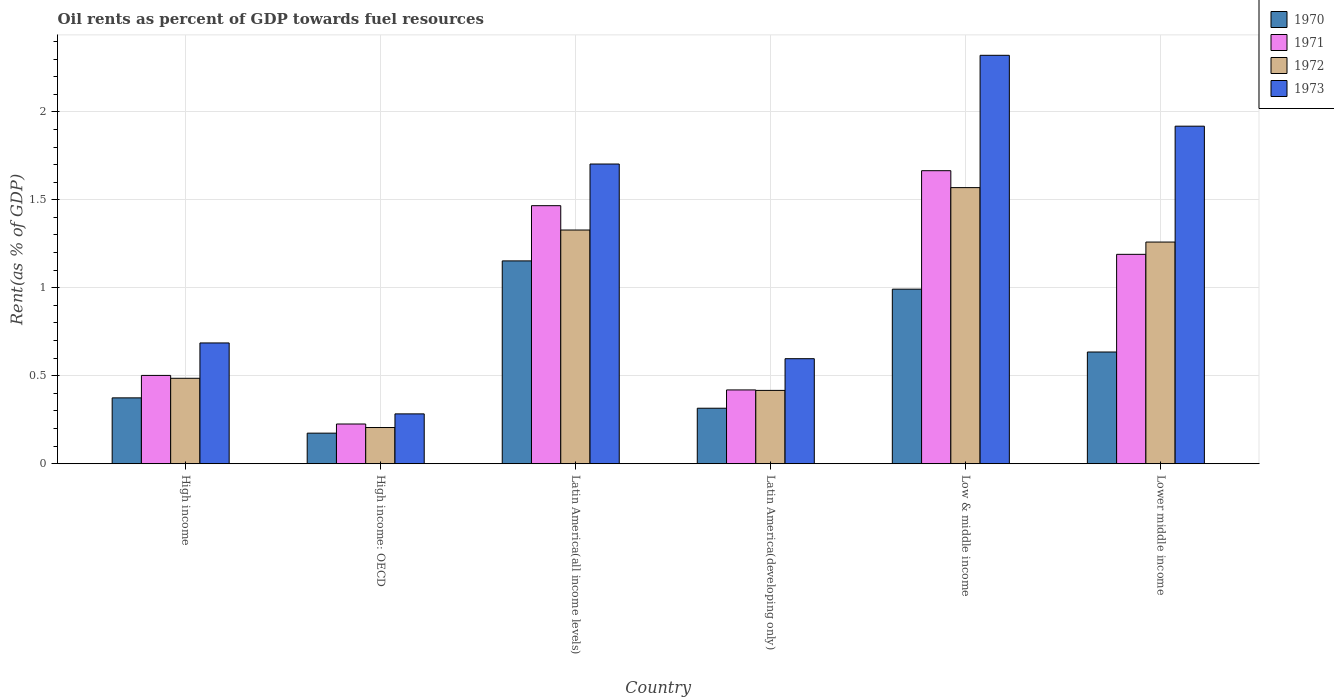How many groups of bars are there?
Your answer should be compact. 6. How many bars are there on the 1st tick from the left?
Your answer should be very brief. 4. What is the label of the 6th group of bars from the left?
Make the answer very short. Lower middle income. What is the oil rent in 1970 in High income: OECD?
Provide a succinct answer. 0.17. Across all countries, what is the maximum oil rent in 1970?
Give a very brief answer. 1.15. Across all countries, what is the minimum oil rent in 1971?
Provide a succinct answer. 0.23. In which country was the oil rent in 1972 maximum?
Offer a very short reply. Low & middle income. In which country was the oil rent in 1972 minimum?
Your answer should be compact. High income: OECD. What is the total oil rent in 1970 in the graph?
Your answer should be very brief. 3.64. What is the difference between the oil rent in 1972 in Latin America(all income levels) and that in Lower middle income?
Your answer should be compact. 0.07. What is the difference between the oil rent in 1971 in Latin America(developing only) and the oil rent in 1973 in Low & middle income?
Offer a very short reply. -1.9. What is the average oil rent in 1972 per country?
Ensure brevity in your answer.  0.88. What is the difference between the oil rent of/in 1972 and oil rent of/in 1971 in Latin America(developing only)?
Offer a terse response. -0. In how many countries, is the oil rent in 1973 greater than 1.3 %?
Provide a short and direct response. 3. What is the ratio of the oil rent in 1972 in High income to that in High income: OECD?
Make the answer very short. 2.36. Is the difference between the oil rent in 1972 in High income: OECD and Low & middle income greater than the difference between the oil rent in 1971 in High income: OECD and Low & middle income?
Provide a succinct answer. Yes. What is the difference between the highest and the second highest oil rent in 1973?
Keep it short and to the point. -0.4. What is the difference between the highest and the lowest oil rent in 1973?
Provide a succinct answer. 2.04. Is the sum of the oil rent in 1971 in Latin America(all income levels) and Latin America(developing only) greater than the maximum oil rent in 1973 across all countries?
Give a very brief answer. No. What does the 2nd bar from the left in Latin America(developing only) represents?
Provide a succinct answer. 1971. What does the 1st bar from the right in High income: OECD represents?
Your response must be concise. 1973. Are all the bars in the graph horizontal?
Provide a short and direct response. No. What is the difference between two consecutive major ticks on the Y-axis?
Offer a terse response. 0.5. Does the graph contain any zero values?
Your response must be concise. No. Does the graph contain grids?
Your answer should be very brief. Yes. What is the title of the graph?
Provide a succinct answer. Oil rents as percent of GDP towards fuel resources. What is the label or title of the Y-axis?
Keep it short and to the point. Rent(as % of GDP). What is the Rent(as % of GDP) in 1970 in High income?
Offer a very short reply. 0.37. What is the Rent(as % of GDP) of 1971 in High income?
Provide a short and direct response. 0.5. What is the Rent(as % of GDP) of 1972 in High income?
Offer a very short reply. 0.49. What is the Rent(as % of GDP) of 1973 in High income?
Offer a very short reply. 0.69. What is the Rent(as % of GDP) in 1970 in High income: OECD?
Offer a very short reply. 0.17. What is the Rent(as % of GDP) in 1971 in High income: OECD?
Ensure brevity in your answer.  0.23. What is the Rent(as % of GDP) of 1972 in High income: OECD?
Your response must be concise. 0.21. What is the Rent(as % of GDP) of 1973 in High income: OECD?
Offer a terse response. 0.28. What is the Rent(as % of GDP) in 1970 in Latin America(all income levels)?
Your response must be concise. 1.15. What is the Rent(as % of GDP) in 1971 in Latin America(all income levels)?
Provide a succinct answer. 1.47. What is the Rent(as % of GDP) in 1972 in Latin America(all income levels)?
Your response must be concise. 1.33. What is the Rent(as % of GDP) of 1973 in Latin America(all income levels)?
Your answer should be compact. 1.7. What is the Rent(as % of GDP) in 1970 in Latin America(developing only)?
Offer a very short reply. 0.32. What is the Rent(as % of GDP) of 1971 in Latin America(developing only)?
Give a very brief answer. 0.42. What is the Rent(as % of GDP) of 1972 in Latin America(developing only)?
Provide a short and direct response. 0.42. What is the Rent(as % of GDP) in 1973 in Latin America(developing only)?
Give a very brief answer. 0.6. What is the Rent(as % of GDP) in 1970 in Low & middle income?
Your response must be concise. 0.99. What is the Rent(as % of GDP) of 1971 in Low & middle income?
Offer a terse response. 1.67. What is the Rent(as % of GDP) of 1972 in Low & middle income?
Ensure brevity in your answer.  1.57. What is the Rent(as % of GDP) of 1973 in Low & middle income?
Ensure brevity in your answer.  2.32. What is the Rent(as % of GDP) in 1970 in Lower middle income?
Your response must be concise. 0.63. What is the Rent(as % of GDP) in 1971 in Lower middle income?
Your answer should be very brief. 1.19. What is the Rent(as % of GDP) of 1972 in Lower middle income?
Your answer should be very brief. 1.26. What is the Rent(as % of GDP) of 1973 in Lower middle income?
Your response must be concise. 1.92. Across all countries, what is the maximum Rent(as % of GDP) of 1970?
Your answer should be very brief. 1.15. Across all countries, what is the maximum Rent(as % of GDP) in 1971?
Give a very brief answer. 1.67. Across all countries, what is the maximum Rent(as % of GDP) of 1972?
Keep it short and to the point. 1.57. Across all countries, what is the maximum Rent(as % of GDP) of 1973?
Your answer should be very brief. 2.32. Across all countries, what is the minimum Rent(as % of GDP) of 1970?
Provide a succinct answer. 0.17. Across all countries, what is the minimum Rent(as % of GDP) of 1971?
Provide a succinct answer. 0.23. Across all countries, what is the minimum Rent(as % of GDP) of 1972?
Keep it short and to the point. 0.21. Across all countries, what is the minimum Rent(as % of GDP) in 1973?
Offer a terse response. 0.28. What is the total Rent(as % of GDP) of 1970 in the graph?
Provide a succinct answer. 3.64. What is the total Rent(as % of GDP) in 1971 in the graph?
Provide a short and direct response. 5.47. What is the total Rent(as % of GDP) in 1972 in the graph?
Provide a succinct answer. 5.27. What is the total Rent(as % of GDP) of 1973 in the graph?
Give a very brief answer. 7.51. What is the difference between the Rent(as % of GDP) of 1970 in High income and that in High income: OECD?
Provide a short and direct response. 0.2. What is the difference between the Rent(as % of GDP) of 1971 in High income and that in High income: OECD?
Your response must be concise. 0.28. What is the difference between the Rent(as % of GDP) in 1972 in High income and that in High income: OECD?
Offer a terse response. 0.28. What is the difference between the Rent(as % of GDP) in 1973 in High income and that in High income: OECD?
Provide a short and direct response. 0.4. What is the difference between the Rent(as % of GDP) in 1970 in High income and that in Latin America(all income levels)?
Give a very brief answer. -0.78. What is the difference between the Rent(as % of GDP) of 1971 in High income and that in Latin America(all income levels)?
Keep it short and to the point. -0.96. What is the difference between the Rent(as % of GDP) in 1972 in High income and that in Latin America(all income levels)?
Provide a short and direct response. -0.84. What is the difference between the Rent(as % of GDP) of 1973 in High income and that in Latin America(all income levels)?
Provide a succinct answer. -1.02. What is the difference between the Rent(as % of GDP) in 1970 in High income and that in Latin America(developing only)?
Offer a terse response. 0.06. What is the difference between the Rent(as % of GDP) in 1971 in High income and that in Latin America(developing only)?
Offer a terse response. 0.08. What is the difference between the Rent(as % of GDP) in 1972 in High income and that in Latin America(developing only)?
Keep it short and to the point. 0.07. What is the difference between the Rent(as % of GDP) of 1973 in High income and that in Latin America(developing only)?
Your answer should be compact. 0.09. What is the difference between the Rent(as % of GDP) of 1970 in High income and that in Low & middle income?
Keep it short and to the point. -0.62. What is the difference between the Rent(as % of GDP) in 1971 in High income and that in Low & middle income?
Make the answer very short. -1.16. What is the difference between the Rent(as % of GDP) in 1972 in High income and that in Low & middle income?
Offer a terse response. -1.08. What is the difference between the Rent(as % of GDP) of 1973 in High income and that in Low & middle income?
Your answer should be very brief. -1.63. What is the difference between the Rent(as % of GDP) of 1970 in High income and that in Lower middle income?
Offer a terse response. -0.26. What is the difference between the Rent(as % of GDP) in 1971 in High income and that in Lower middle income?
Give a very brief answer. -0.69. What is the difference between the Rent(as % of GDP) in 1972 in High income and that in Lower middle income?
Your answer should be very brief. -0.77. What is the difference between the Rent(as % of GDP) in 1973 in High income and that in Lower middle income?
Your answer should be very brief. -1.23. What is the difference between the Rent(as % of GDP) in 1970 in High income: OECD and that in Latin America(all income levels)?
Make the answer very short. -0.98. What is the difference between the Rent(as % of GDP) in 1971 in High income: OECD and that in Latin America(all income levels)?
Your answer should be compact. -1.24. What is the difference between the Rent(as % of GDP) of 1972 in High income: OECD and that in Latin America(all income levels)?
Keep it short and to the point. -1.12. What is the difference between the Rent(as % of GDP) in 1973 in High income: OECD and that in Latin America(all income levels)?
Your response must be concise. -1.42. What is the difference between the Rent(as % of GDP) in 1970 in High income: OECD and that in Latin America(developing only)?
Ensure brevity in your answer.  -0.14. What is the difference between the Rent(as % of GDP) of 1971 in High income: OECD and that in Latin America(developing only)?
Provide a short and direct response. -0.19. What is the difference between the Rent(as % of GDP) of 1972 in High income: OECD and that in Latin America(developing only)?
Your answer should be very brief. -0.21. What is the difference between the Rent(as % of GDP) of 1973 in High income: OECD and that in Latin America(developing only)?
Your response must be concise. -0.31. What is the difference between the Rent(as % of GDP) in 1970 in High income: OECD and that in Low & middle income?
Your answer should be very brief. -0.82. What is the difference between the Rent(as % of GDP) of 1971 in High income: OECD and that in Low & middle income?
Your answer should be very brief. -1.44. What is the difference between the Rent(as % of GDP) in 1972 in High income: OECD and that in Low & middle income?
Offer a terse response. -1.36. What is the difference between the Rent(as % of GDP) in 1973 in High income: OECD and that in Low & middle income?
Ensure brevity in your answer.  -2.04. What is the difference between the Rent(as % of GDP) of 1970 in High income: OECD and that in Lower middle income?
Keep it short and to the point. -0.46. What is the difference between the Rent(as % of GDP) of 1971 in High income: OECD and that in Lower middle income?
Make the answer very short. -0.96. What is the difference between the Rent(as % of GDP) in 1972 in High income: OECD and that in Lower middle income?
Your answer should be compact. -1.05. What is the difference between the Rent(as % of GDP) of 1973 in High income: OECD and that in Lower middle income?
Your answer should be compact. -1.64. What is the difference between the Rent(as % of GDP) in 1970 in Latin America(all income levels) and that in Latin America(developing only)?
Your response must be concise. 0.84. What is the difference between the Rent(as % of GDP) of 1971 in Latin America(all income levels) and that in Latin America(developing only)?
Your answer should be very brief. 1.05. What is the difference between the Rent(as % of GDP) in 1972 in Latin America(all income levels) and that in Latin America(developing only)?
Provide a short and direct response. 0.91. What is the difference between the Rent(as % of GDP) of 1973 in Latin America(all income levels) and that in Latin America(developing only)?
Offer a terse response. 1.11. What is the difference between the Rent(as % of GDP) of 1970 in Latin America(all income levels) and that in Low & middle income?
Your answer should be compact. 0.16. What is the difference between the Rent(as % of GDP) in 1971 in Latin America(all income levels) and that in Low & middle income?
Offer a terse response. -0.2. What is the difference between the Rent(as % of GDP) of 1972 in Latin America(all income levels) and that in Low & middle income?
Your response must be concise. -0.24. What is the difference between the Rent(as % of GDP) in 1973 in Latin America(all income levels) and that in Low & middle income?
Your answer should be compact. -0.62. What is the difference between the Rent(as % of GDP) of 1970 in Latin America(all income levels) and that in Lower middle income?
Provide a succinct answer. 0.52. What is the difference between the Rent(as % of GDP) in 1971 in Latin America(all income levels) and that in Lower middle income?
Keep it short and to the point. 0.28. What is the difference between the Rent(as % of GDP) in 1972 in Latin America(all income levels) and that in Lower middle income?
Offer a very short reply. 0.07. What is the difference between the Rent(as % of GDP) in 1973 in Latin America(all income levels) and that in Lower middle income?
Offer a very short reply. -0.21. What is the difference between the Rent(as % of GDP) of 1970 in Latin America(developing only) and that in Low & middle income?
Keep it short and to the point. -0.68. What is the difference between the Rent(as % of GDP) in 1971 in Latin America(developing only) and that in Low & middle income?
Keep it short and to the point. -1.25. What is the difference between the Rent(as % of GDP) in 1972 in Latin America(developing only) and that in Low & middle income?
Make the answer very short. -1.15. What is the difference between the Rent(as % of GDP) of 1973 in Latin America(developing only) and that in Low & middle income?
Make the answer very short. -1.72. What is the difference between the Rent(as % of GDP) of 1970 in Latin America(developing only) and that in Lower middle income?
Provide a succinct answer. -0.32. What is the difference between the Rent(as % of GDP) of 1971 in Latin America(developing only) and that in Lower middle income?
Offer a terse response. -0.77. What is the difference between the Rent(as % of GDP) in 1972 in Latin America(developing only) and that in Lower middle income?
Your response must be concise. -0.84. What is the difference between the Rent(as % of GDP) in 1973 in Latin America(developing only) and that in Lower middle income?
Your answer should be compact. -1.32. What is the difference between the Rent(as % of GDP) of 1970 in Low & middle income and that in Lower middle income?
Your answer should be very brief. 0.36. What is the difference between the Rent(as % of GDP) of 1971 in Low & middle income and that in Lower middle income?
Ensure brevity in your answer.  0.48. What is the difference between the Rent(as % of GDP) of 1972 in Low & middle income and that in Lower middle income?
Offer a very short reply. 0.31. What is the difference between the Rent(as % of GDP) of 1973 in Low & middle income and that in Lower middle income?
Provide a short and direct response. 0.4. What is the difference between the Rent(as % of GDP) in 1970 in High income and the Rent(as % of GDP) in 1971 in High income: OECD?
Your answer should be compact. 0.15. What is the difference between the Rent(as % of GDP) of 1970 in High income and the Rent(as % of GDP) of 1972 in High income: OECD?
Keep it short and to the point. 0.17. What is the difference between the Rent(as % of GDP) of 1970 in High income and the Rent(as % of GDP) of 1973 in High income: OECD?
Provide a succinct answer. 0.09. What is the difference between the Rent(as % of GDP) of 1971 in High income and the Rent(as % of GDP) of 1972 in High income: OECD?
Your response must be concise. 0.3. What is the difference between the Rent(as % of GDP) of 1971 in High income and the Rent(as % of GDP) of 1973 in High income: OECD?
Offer a very short reply. 0.22. What is the difference between the Rent(as % of GDP) in 1972 in High income and the Rent(as % of GDP) in 1973 in High income: OECD?
Offer a very short reply. 0.2. What is the difference between the Rent(as % of GDP) in 1970 in High income and the Rent(as % of GDP) in 1971 in Latin America(all income levels)?
Keep it short and to the point. -1.09. What is the difference between the Rent(as % of GDP) of 1970 in High income and the Rent(as % of GDP) of 1972 in Latin America(all income levels)?
Keep it short and to the point. -0.95. What is the difference between the Rent(as % of GDP) of 1970 in High income and the Rent(as % of GDP) of 1973 in Latin America(all income levels)?
Your answer should be very brief. -1.33. What is the difference between the Rent(as % of GDP) in 1971 in High income and the Rent(as % of GDP) in 1972 in Latin America(all income levels)?
Provide a succinct answer. -0.83. What is the difference between the Rent(as % of GDP) in 1971 in High income and the Rent(as % of GDP) in 1973 in Latin America(all income levels)?
Your answer should be very brief. -1.2. What is the difference between the Rent(as % of GDP) of 1972 in High income and the Rent(as % of GDP) of 1973 in Latin America(all income levels)?
Your answer should be very brief. -1.22. What is the difference between the Rent(as % of GDP) in 1970 in High income and the Rent(as % of GDP) in 1971 in Latin America(developing only)?
Your answer should be very brief. -0.05. What is the difference between the Rent(as % of GDP) of 1970 in High income and the Rent(as % of GDP) of 1972 in Latin America(developing only)?
Your answer should be very brief. -0.04. What is the difference between the Rent(as % of GDP) in 1970 in High income and the Rent(as % of GDP) in 1973 in Latin America(developing only)?
Ensure brevity in your answer.  -0.22. What is the difference between the Rent(as % of GDP) in 1971 in High income and the Rent(as % of GDP) in 1972 in Latin America(developing only)?
Make the answer very short. 0.09. What is the difference between the Rent(as % of GDP) of 1971 in High income and the Rent(as % of GDP) of 1973 in Latin America(developing only)?
Your response must be concise. -0.1. What is the difference between the Rent(as % of GDP) of 1972 in High income and the Rent(as % of GDP) of 1973 in Latin America(developing only)?
Your answer should be compact. -0.11. What is the difference between the Rent(as % of GDP) in 1970 in High income and the Rent(as % of GDP) in 1971 in Low & middle income?
Provide a succinct answer. -1.29. What is the difference between the Rent(as % of GDP) in 1970 in High income and the Rent(as % of GDP) in 1972 in Low & middle income?
Give a very brief answer. -1.19. What is the difference between the Rent(as % of GDP) of 1970 in High income and the Rent(as % of GDP) of 1973 in Low & middle income?
Provide a short and direct response. -1.95. What is the difference between the Rent(as % of GDP) in 1971 in High income and the Rent(as % of GDP) in 1972 in Low & middle income?
Your response must be concise. -1.07. What is the difference between the Rent(as % of GDP) of 1971 in High income and the Rent(as % of GDP) of 1973 in Low & middle income?
Your answer should be compact. -1.82. What is the difference between the Rent(as % of GDP) in 1972 in High income and the Rent(as % of GDP) in 1973 in Low & middle income?
Give a very brief answer. -1.84. What is the difference between the Rent(as % of GDP) of 1970 in High income and the Rent(as % of GDP) of 1971 in Lower middle income?
Your answer should be compact. -0.82. What is the difference between the Rent(as % of GDP) in 1970 in High income and the Rent(as % of GDP) in 1972 in Lower middle income?
Offer a terse response. -0.89. What is the difference between the Rent(as % of GDP) in 1970 in High income and the Rent(as % of GDP) in 1973 in Lower middle income?
Provide a short and direct response. -1.54. What is the difference between the Rent(as % of GDP) in 1971 in High income and the Rent(as % of GDP) in 1972 in Lower middle income?
Your answer should be very brief. -0.76. What is the difference between the Rent(as % of GDP) in 1971 in High income and the Rent(as % of GDP) in 1973 in Lower middle income?
Ensure brevity in your answer.  -1.42. What is the difference between the Rent(as % of GDP) of 1972 in High income and the Rent(as % of GDP) of 1973 in Lower middle income?
Offer a very short reply. -1.43. What is the difference between the Rent(as % of GDP) of 1970 in High income: OECD and the Rent(as % of GDP) of 1971 in Latin America(all income levels)?
Your response must be concise. -1.29. What is the difference between the Rent(as % of GDP) in 1970 in High income: OECD and the Rent(as % of GDP) in 1972 in Latin America(all income levels)?
Ensure brevity in your answer.  -1.15. What is the difference between the Rent(as % of GDP) in 1970 in High income: OECD and the Rent(as % of GDP) in 1973 in Latin America(all income levels)?
Your response must be concise. -1.53. What is the difference between the Rent(as % of GDP) of 1971 in High income: OECD and the Rent(as % of GDP) of 1972 in Latin America(all income levels)?
Your answer should be very brief. -1.1. What is the difference between the Rent(as % of GDP) of 1971 in High income: OECD and the Rent(as % of GDP) of 1973 in Latin America(all income levels)?
Give a very brief answer. -1.48. What is the difference between the Rent(as % of GDP) in 1972 in High income: OECD and the Rent(as % of GDP) in 1973 in Latin America(all income levels)?
Provide a succinct answer. -1.5. What is the difference between the Rent(as % of GDP) in 1970 in High income: OECD and the Rent(as % of GDP) in 1971 in Latin America(developing only)?
Ensure brevity in your answer.  -0.25. What is the difference between the Rent(as % of GDP) of 1970 in High income: OECD and the Rent(as % of GDP) of 1972 in Latin America(developing only)?
Offer a very short reply. -0.24. What is the difference between the Rent(as % of GDP) in 1970 in High income: OECD and the Rent(as % of GDP) in 1973 in Latin America(developing only)?
Your answer should be compact. -0.42. What is the difference between the Rent(as % of GDP) in 1971 in High income: OECD and the Rent(as % of GDP) in 1972 in Latin America(developing only)?
Make the answer very short. -0.19. What is the difference between the Rent(as % of GDP) of 1971 in High income: OECD and the Rent(as % of GDP) of 1973 in Latin America(developing only)?
Ensure brevity in your answer.  -0.37. What is the difference between the Rent(as % of GDP) of 1972 in High income: OECD and the Rent(as % of GDP) of 1973 in Latin America(developing only)?
Ensure brevity in your answer.  -0.39. What is the difference between the Rent(as % of GDP) in 1970 in High income: OECD and the Rent(as % of GDP) in 1971 in Low & middle income?
Make the answer very short. -1.49. What is the difference between the Rent(as % of GDP) of 1970 in High income: OECD and the Rent(as % of GDP) of 1972 in Low & middle income?
Make the answer very short. -1.4. What is the difference between the Rent(as % of GDP) of 1970 in High income: OECD and the Rent(as % of GDP) of 1973 in Low & middle income?
Ensure brevity in your answer.  -2.15. What is the difference between the Rent(as % of GDP) of 1971 in High income: OECD and the Rent(as % of GDP) of 1972 in Low & middle income?
Your answer should be compact. -1.34. What is the difference between the Rent(as % of GDP) of 1971 in High income: OECD and the Rent(as % of GDP) of 1973 in Low & middle income?
Provide a short and direct response. -2.1. What is the difference between the Rent(as % of GDP) of 1972 in High income: OECD and the Rent(as % of GDP) of 1973 in Low & middle income?
Offer a very short reply. -2.12. What is the difference between the Rent(as % of GDP) in 1970 in High income: OECD and the Rent(as % of GDP) in 1971 in Lower middle income?
Your answer should be very brief. -1.02. What is the difference between the Rent(as % of GDP) of 1970 in High income: OECD and the Rent(as % of GDP) of 1972 in Lower middle income?
Ensure brevity in your answer.  -1.09. What is the difference between the Rent(as % of GDP) in 1970 in High income: OECD and the Rent(as % of GDP) in 1973 in Lower middle income?
Make the answer very short. -1.74. What is the difference between the Rent(as % of GDP) in 1971 in High income: OECD and the Rent(as % of GDP) in 1972 in Lower middle income?
Offer a very short reply. -1.03. What is the difference between the Rent(as % of GDP) of 1971 in High income: OECD and the Rent(as % of GDP) of 1973 in Lower middle income?
Make the answer very short. -1.69. What is the difference between the Rent(as % of GDP) in 1972 in High income: OECD and the Rent(as % of GDP) in 1973 in Lower middle income?
Offer a very short reply. -1.71. What is the difference between the Rent(as % of GDP) of 1970 in Latin America(all income levels) and the Rent(as % of GDP) of 1971 in Latin America(developing only)?
Ensure brevity in your answer.  0.73. What is the difference between the Rent(as % of GDP) in 1970 in Latin America(all income levels) and the Rent(as % of GDP) in 1972 in Latin America(developing only)?
Give a very brief answer. 0.74. What is the difference between the Rent(as % of GDP) of 1970 in Latin America(all income levels) and the Rent(as % of GDP) of 1973 in Latin America(developing only)?
Your answer should be compact. 0.56. What is the difference between the Rent(as % of GDP) in 1971 in Latin America(all income levels) and the Rent(as % of GDP) in 1972 in Latin America(developing only)?
Offer a terse response. 1.05. What is the difference between the Rent(as % of GDP) of 1971 in Latin America(all income levels) and the Rent(as % of GDP) of 1973 in Latin America(developing only)?
Give a very brief answer. 0.87. What is the difference between the Rent(as % of GDP) of 1972 in Latin America(all income levels) and the Rent(as % of GDP) of 1973 in Latin America(developing only)?
Your response must be concise. 0.73. What is the difference between the Rent(as % of GDP) in 1970 in Latin America(all income levels) and the Rent(as % of GDP) in 1971 in Low & middle income?
Your response must be concise. -0.51. What is the difference between the Rent(as % of GDP) of 1970 in Latin America(all income levels) and the Rent(as % of GDP) of 1972 in Low & middle income?
Offer a very short reply. -0.42. What is the difference between the Rent(as % of GDP) in 1970 in Latin America(all income levels) and the Rent(as % of GDP) in 1973 in Low & middle income?
Offer a very short reply. -1.17. What is the difference between the Rent(as % of GDP) in 1971 in Latin America(all income levels) and the Rent(as % of GDP) in 1972 in Low & middle income?
Ensure brevity in your answer.  -0.1. What is the difference between the Rent(as % of GDP) of 1971 in Latin America(all income levels) and the Rent(as % of GDP) of 1973 in Low & middle income?
Your answer should be compact. -0.85. What is the difference between the Rent(as % of GDP) in 1972 in Latin America(all income levels) and the Rent(as % of GDP) in 1973 in Low & middle income?
Give a very brief answer. -0.99. What is the difference between the Rent(as % of GDP) of 1970 in Latin America(all income levels) and the Rent(as % of GDP) of 1971 in Lower middle income?
Offer a terse response. -0.04. What is the difference between the Rent(as % of GDP) in 1970 in Latin America(all income levels) and the Rent(as % of GDP) in 1972 in Lower middle income?
Provide a succinct answer. -0.11. What is the difference between the Rent(as % of GDP) in 1970 in Latin America(all income levels) and the Rent(as % of GDP) in 1973 in Lower middle income?
Offer a terse response. -0.77. What is the difference between the Rent(as % of GDP) in 1971 in Latin America(all income levels) and the Rent(as % of GDP) in 1972 in Lower middle income?
Offer a terse response. 0.21. What is the difference between the Rent(as % of GDP) of 1971 in Latin America(all income levels) and the Rent(as % of GDP) of 1973 in Lower middle income?
Provide a short and direct response. -0.45. What is the difference between the Rent(as % of GDP) of 1972 in Latin America(all income levels) and the Rent(as % of GDP) of 1973 in Lower middle income?
Offer a very short reply. -0.59. What is the difference between the Rent(as % of GDP) of 1970 in Latin America(developing only) and the Rent(as % of GDP) of 1971 in Low & middle income?
Provide a succinct answer. -1.35. What is the difference between the Rent(as % of GDP) of 1970 in Latin America(developing only) and the Rent(as % of GDP) of 1972 in Low & middle income?
Give a very brief answer. -1.25. What is the difference between the Rent(as % of GDP) of 1970 in Latin America(developing only) and the Rent(as % of GDP) of 1973 in Low & middle income?
Make the answer very short. -2.01. What is the difference between the Rent(as % of GDP) in 1971 in Latin America(developing only) and the Rent(as % of GDP) in 1972 in Low & middle income?
Make the answer very short. -1.15. What is the difference between the Rent(as % of GDP) in 1971 in Latin America(developing only) and the Rent(as % of GDP) in 1973 in Low & middle income?
Provide a succinct answer. -1.9. What is the difference between the Rent(as % of GDP) of 1972 in Latin America(developing only) and the Rent(as % of GDP) of 1973 in Low & middle income?
Keep it short and to the point. -1.9. What is the difference between the Rent(as % of GDP) of 1970 in Latin America(developing only) and the Rent(as % of GDP) of 1971 in Lower middle income?
Give a very brief answer. -0.87. What is the difference between the Rent(as % of GDP) in 1970 in Latin America(developing only) and the Rent(as % of GDP) in 1972 in Lower middle income?
Your answer should be compact. -0.94. What is the difference between the Rent(as % of GDP) in 1970 in Latin America(developing only) and the Rent(as % of GDP) in 1973 in Lower middle income?
Your answer should be compact. -1.6. What is the difference between the Rent(as % of GDP) of 1971 in Latin America(developing only) and the Rent(as % of GDP) of 1972 in Lower middle income?
Your answer should be very brief. -0.84. What is the difference between the Rent(as % of GDP) in 1971 in Latin America(developing only) and the Rent(as % of GDP) in 1973 in Lower middle income?
Ensure brevity in your answer.  -1.5. What is the difference between the Rent(as % of GDP) of 1972 in Latin America(developing only) and the Rent(as % of GDP) of 1973 in Lower middle income?
Keep it short and to the point. -1.5. What is the difference between the Rent(as % of GDP) in 1970 in Low & middle income and the Rent(as % of GDP) in 1971 in Lower middle income?
Your answer should be very brief. -0.2. What is the difference between the Rent(as % of GDP) of 1970 in Low & middle income and the Rent(as % of GDP) of 1972 in Lower middle income?
Offer a very short reply. -0.27. What is the difference between the Rent(as % of GDP) of 1970 in Low & middle income and the Rent(as % of GDP) of 1973 in Lower middle income?
Make the answer very short. -0.93. What is the difference between the Rent(as % of GDP) in 1971 in Low & middle income and the Rent(as % of GDP) in 1972 in Lower middle income?
Your response must be concise. 0.41. What is the difference between the Rent(as % of GDP) of 1971 in Low & middle income and the Rent(as % of GDP) of 1973 in Lower middle income?
Make the answer very short. -0.25. What is the difference between the Rent(as % of GDP) of 1972 in Low & middle income and the Rent(as % of GDP) of 1973 in Lower middle income?
Provide a succinct answer. -0.35. What is the average Rent(as % of GDP) in 1970 per country?
Your response must be concise. 0.61. What is the average Rent(as % of GDP) in 1971 per country?
Keep it short and to the point. 0.91. What is the average Rent(as % of GDP) in 1972 per country?
Offer a terse response. 0.88. What is the average Rent(as % of GDP) in 1973 per country?
Offer a terse response. 1.25. What is the difference between the Rent(as % of GDP) of 1970 and Rent(as % of GDP) of 1971 in High income?
Your response must be concise. -0.13. What is the difference between the Rent(as % of GDP) in 1970 and Rent(as % of GDP) in 1972 in High income?
Your answer should be very brief. -0.11. What is the difference between the Rent(as % of GDP) in 1970 and Rent(as % of GDP) in 1973 in High income?
Keep it short and to the point. -0.31. What is the difference between the Rent(as % of GDP) of 1971 and Rent(as % of GDP) of 1972 in High income?
Offer a very short reply. 0.02. What is the difference between the Rent(as % of GDP) in 1971 and Rent(as % of GDP) in 1973 in High income?
Ensure brevity in your answer.  -0.18. What is the difference between the Rent(as % of GDP) of 1972 and Rent(as % of GDP) of 1973 in High income?
Provide a short and direct response. -0.2. What is the difference between the Rent(as % of GDP) of 1970 and Rent(as % of GDP) of 1971 in High income: OECD?
Your answer should be very brief. -0.05. What is the difference between the Rent(as % of GDP) of 1970 and Rent(as % of GDP) of 1972 in High income: OECD?
Provide a short and direct response. -0.03. What is the difference between the Rent(as % of GDP) in 1970 and Rent(as % of GDP) in 1973 in High income: OECD?
Provide a short and direct response. -0.11. What is the difference between the Rent(as % of GDP) of 1971 and Rent(as % of GDP) of 1973 in High income: OECD?
Your answer should be very brief. -0.06. What is the difference between the Rent(as % of GDP) in 1972 and Rent(as % of GDP) in 1973 in High income: OECD?
Offer a very short reply. -0.08. What is the difference between the Rent(as % of GDP) of 1970 and Rent(as % of GDP) of 1971 in Latin America(all income levels)?
Your response must be concise. -0.31. What is the difference between the Rent(as % of GDP) in 1970 and Rent(as % of GDP) in 1972 in Latin America(all income levels)?
Your response must be concise. -0.18. What is the difference between the Rent(as % of GDP) in 1970 and Rent(as % of GDP) in 1973 in Latin America(all income levels)?
Your response must be concise. -0.55. What is the difference between the Rent(as % of GDP) in 1971 and Rent(as % of GDP) in 1972 in Latin America(all income levels)?
Provide a succinct answer. 0.14. What is the difference between the Rent(as % of GDP) in 1971 and Rent(as % of GDP) in 1973 in Latin America(all income levels)?
Give a very brief answer. -0.24. What is the difference between the Rent(as % of GDP) in 1972 and Rent(as % of GDP) in 1973 in Latin America(all income levels)?
Offer a terse response. -0.38. What is the difference between the Rent(as % of GDP) of 1970 and Rent(as % of GDP) of 1971 in Latin America(developing only)?
Offer a terse response. -0.1. What is the difference between the Rent(as % of GDP) in 1970 and Rent(as % of GDP) in 1972 in Latin America(developing only)?
Make the answer very short. -0.1. What is the difference between the Rent(as % of GDP) of 1970 and Rent(as % of GDP) of 1973 in Latin America(developing only)?
Make the answer very short. -0.28. What is the difference between the Rent(as % of GDP) in 1971 and Rent(as % of GDP) in 1972 in Latin America(developing only)?
Your answer should be compact. 0. What is the difference between the Rent(as % of GDP) in 1971 and Rent(as % of GDP) in 1973 in Latin America(developing only)?
Keep it short and to the point. -0.18. What is the difference between the Rent(as % of GDP) in 1972 and Rent(as % of GDP) in 1973 in Latin America(developing only)?
Your response must be concise. -0.18. What is the difference between the Rent(as % of GDP) of 1970 and Rent(as % of GDP) of 1971 in Low & middle income?
Your answer should be very brief. -0.67. What is the difference between the Rent(as % of GDP) in 1970 and Rent(as % of GDP) in 1972 in Low & middle income?
Keep it short and to the point. -0.58. What is the difference between the Rent(as % of GDP) of 1970 and Rent(as % of GDP) of 1973 in Low & middle income?
Your answer should be compact. -1.33. What is the difference between the Rent(as % of GDP) of 1971 and Rent(as % of GDP) of 1972 in Low & middle income?
Provide a succinct answer. 0.1. What is the difference between the Rent(as % of GDP) in 1971 and Rent(as % of GDP) in 1973 in Low & middle income?
Ensure brevity in your answer.  -0.66. What is the difference between the Rent(as % of GDP) of 1972 and Rent(as % of GDP) of 1973 in Low & middle income?
Give a very brief answer. -0.75. What is the difference between the Rent(as % of GDP) in 1970 and Rent(as % of GDP) in 1971 in Lower middle income?
Your response must be concise. -0.56. What is the difference between the Rent(as % of GDP) of 1970 and Rent(as % of GDP) of 1972 in Lower middle income?
Your answer should be compact. -0.62. What is the difference between the Rent(as % of GDP) of 1970 and Rent(as % of GDP) of 1973 in Lower middle income?
Offer a very short reply. -1.28. What is the difference between the Rent(as % of GDP) in 1971 and Rent(as % of GDP) in 1972 in Lower middle income?
Offer a terse response. -0.07. What is the difference between the Rent(as % of GDP) in 1971 and Rent(as % of GDP) in 1973 in Lower middle income?
Give a very brief answer. -0.73. What is the difference between the Rent(as % of GDP) in 1972 and Rent(as % of GDP) in 1973 in Lower middle income?
Give a very brief answer. -0.66. What is the ratio of the Rent(as % of GDP) of 1970 in High income to that in High income: OECD?
Your response must be concise. 2.15. What is the ratio of the Rent(as % of GDP) of 1971 in High income to that in High income: OECD?
Your answer should be very brief. 2.22. What is the ratio of the Rent(as % of GDP) of 1972 in High income to that in High income: OECD?
Your answer should be very brief. 2.36. What is the ratio of the Rent(as % of GDP) in 1973 in High income to that in High income: OECD?
Give a very brief answer. 2.42. What is the ratio of the Rent(as % of GDP) in 1970 in High income to that in Latin America(all income levels)?
Keep it short and to the point. 0.32. What is the ratio of the Rent(as % of GDP) in 1971 in High income to that in Latin America(all income levels)?
Your answer should be compact. 0.34. What is the ratio of the Rent(as % of GDP) in 1972 in High income to that in Latin America(all income levels)?
Offer a very short reply. 0.37. What is the ratio of the Rent(as % of GDP) in 1973 in High income to that in Latin America(all income levels)?
Your answer should be compact. 0.4. What is the ratio of the Rent(as % of GDP) in 1970 in High income to that in Latin America(developing only)?
Keep it short and to the point. 1.19. What is the ratio of the Rent(as % of GDP) of 1971 in High income to that in Latin America(developing only)?
Your response must be concise. 1.2. What is the ratio of the Rent(as % of GDP) in 1972 in High income to that in Latin America(developing only)?
Provide a short and direct response. 1.17. What is the ratio of the Rent(as % of GDP) in 1973 in High income to that in Latin America(developing only)?
Ensure brevity in your answer.  1.15. What is the ratio of the Rent(as % of GDP) in 1970 in High income to that in Low & middle income?
Give a very brief answer. 0.38. What is the ratio of the Rent(as % of GDP) in 1971 in High income to that in Low & middle income?
Keep it short and to the point. 0.3. What is the ratio of the Rent(as % of GDP) in 1972 in High income to that in Low & middle income?
Offer a terse response. 0.31. What is the ratio of the Rent(as % of GDP) in 1973 in High income to that in Low & middle income?
Provide a short and direct response. 0.3. What is the ratio of the Rent(as % of GDP) of 1970 in High income to that in Lower middle income?
Provide a succinct answer. 0.59. What is the ratio of the Rent(as % of GDP) in 1971 in High income to that in Lower middle income?
Offer a very short reply. 0.42. What is the ratio of the Rent(as % of GDP) in 1972 in High income to that in Lower middle income?
Offer a very short reply. 0.39. What is the ratio of the Rent(as % of GDP) of 1973 in High income to that in Lower middle income?
Your response must be concise. 0.36. What is the ratio of the Rent(as % of GDP) in 1970 in High income: OECD to that in Latin America(all income levels)?
Ensure brevity in your answer.  0.15. What is the ratio of the Rent(as % of GDP) of 1971 in High income: OECD to that in Latin America(all income levels)?
Offer a terse response. 0.15. What is the ratio of the Rent(as % of GDP) in 1972 in High income: OECD to that in Latin America(all income levels)?
Ensure brevity in your answer.  0.15. What is the ratio of the Rent(as % of GDP) of 1973 in High income: OECD to that in Latin America(all income levels)?
Your answer should be compact. 0.17. What is the ratio of the Rent(as % of GDP) of 1970 in High income: OECD to that in Latin America(developing only)?
Your answer should be compact. 0.55. What is the ratio of the Rent(as % of GDP) of 1971 in High income: OECD to that in Latin America(developing only)?
Your answer should be compact. 0.54. What is the ratio of the Rent(as % of GDP) of 1972 in High income: OECD to that in Latin America(developing only)?
Make the answer very short. 0.49. What is the ratio of the Rent(as % of GDP) of 1973 in High income: OECD to that in Latin America(developing only)?
Give a very brief answer. 0.47. What is the ratio of the Rent(as % of GDP) in 1970 in High income: OECD to that in Low & middle income?
Provide a short and direct response. 0.18. What is the ratio of the Rent(as % of GDP) in 1971 in High income: OECD to that in Low & middle income?
Give a very brief answer. 0.14. What is the ratio of the Rent(as % of GDP) in 1972 in High income: OECD to that in Low & middle income?
Make the answer very short. 0.13. What is the ratio of the Rent(as % of GDP) in 1973 in High income: OECD to that in Low & middle income?
Make the answer very short. 0.12. What is the ratio of the Rent(as % of GDP) in 1970 in High income: OECD to that in Lower middle income?
Make the answer very short. 0.27. What is the ratio of the Rent(as % of GDP) of 1971 in High income: OECD to that in Lower middle income?
Keep it short and to the point. 0.19. What is the ratio of the Rent(as % of GDP) of 1972 in High income: OECD to that in Lower middle income?
Offer a very short reply. 0.16. What is the ratio of the Rent(as % of GDP) in 1973 in High income: OECD to that in Lower middle income?
Provide a succinct answer. 0.15. What is the ratio of the Rent(as % of GDP) of 1970 in Latin America(all income levels) to that in Latin America(developing only)?
Your response must be concise. 3.65. What is the ratio of the Rent(as % of GDP) in 1971 in Latin America(all income levels) to that in Latin America(developing only)?
Your response must be concise. 3.5. What is the ratio of the Rent(as % of GDP) in 1972 in Latin America(all income levels) to that in Latin America(developing only)?
Keep it short and to the point. 3.19. What is the ratio of the Rent(as % of GDP) in 1973 in Latin America(all income levels) to that in Latin America(developing only)?
Offer a terse response. 2.85. What is the ratio of the Rent(as % of GDP) in 1970 in Latin America(all income levels) to that in Low & middle income?
Your response must be concise. 1.16. What is the ratio of the Rent(as % of GDP) in 1971 in Latin America(all income levels) to that in Low & middle income?
Offer a terse response. 0.88. What is the ratio of the Rent(as % of GDP) of 1972 in Latin America(all income levels) to that in Low & middle income?
Provide a short and direct response. 0.85. What is the ratio of the Rent(as % of GDP) of 1973 in Latin America(all income levels) to that in Low & middle income?
Your response must be concise. 0.73. What is the ratio of the Rent(as % of GDP) in 1970 in Latin America(all income levels) to that in Lower middle income?
Give a very brief answer. 1.82. What is the ratio of the Rent(as % of GDP) of 1971 in Latin America(all income levels) to that in Lower middle income?
Ensure brevity in your answer.  1.23. What is the ratio of the Rent(as % of GDP) of 1972 in Latin America(all income levels) to that in Lower middle income?
Provide a succinct answer. 1.05. What is the ratio of the Rent(as % of GDP) of 1973 in Latin America(all income levels) to that in Lower middle income?
Offer a terse response. 0.89. What is the ratio of the Rent(as % of GDP) of 1970 in Latin America(developing only) to that in Low & middle income?
Ensure brevity in your answer.  0.32. What is the ratio of the Rent(as % of GDP) in 1971 in Latin America(developing only) to that in Low & middle income?
Your response must be concise. 0.25. What is the ratio of the Rent(as % of GDP) of 1972 in Latin America(developing only) to that in Low & middle income?
Ensure brevity in your answer.  0.27. What is the ratio of the Rent(as % of GDP) of 1973 in Latin America(developing only) to that in Low & middle income?
Your response must be concise. 0.26. What is the ratio of the Rent(as % of GDP) of 1970 in Latin America(developing only) to that in Lower middle income?
Provide a succinct answer. 0.5. What is the ratio of the Rent(as % of GDP) in 1971 in Latin America(developing only) to that in Lower middle income?
Make the answer very short. 0.35. What is the ratio of the Rent(as % of GDP) of 1972 in Latin America(developing only) to that in Lower middle income?
Offer a very short reply. 0.33. What is the ratio of the Rent(as % of GDP) in 1973 in Latin America(developing only) to that in Lower middle income?
Your answer should be compact. 0.31. What is the ratio of the Rent(as % of GDP) of 1970 in Low & middle income to that in Lower middle income?
Make the answer very short. 1.56. What is the ratio of the Rent(as % of GDP) of 1971 in Low & middle income to that in Lower middle income?
Provide a succinct answer. 1.4. What is the ratio of the Rent(as % of GDP) in 1972 in Low & middle income to that in Lower middle income?
Your response must be concise. 1.25. What is the ratio of the Rent(as % of GDP) in 1973 in Low & middle income to that in Lower middle income?
Keep it short and to the point. 1.21. What is the difference between the highest and the second highest Rent(as % of GDP) in 1970?
Ensure brevity in your answer.  0.16. What is the difference between the highest and the second highest Rent(as % of GDP) of 1971?
Your answer should be very brief. 0.2. What is the difference between the highest and the second highest Rent(as % of GDP) in 1972?
Offer a terse response. 0.24. What is the difference between the highest and the second highest Rent(as % of GDP) of 1973?
Ensure brevity in your answer.  0.4. What is the difference between the highest and the lowest Rent(as % of GDP) in 1970?
Your answer should be very brief. 0.98. What is the difference between the highest and the lowest Rent(as % of GDP) of 1971?
Keep it short and to the point. 1.44. What is the difference between the highest and the lowest Rent(as % of GDP) in 1972?
Your answer should be compact. 1.36. What is the difference between the highest and the lowest Rent(as % of GDP) in 1973?
Your answer should be compact. 2.04. 